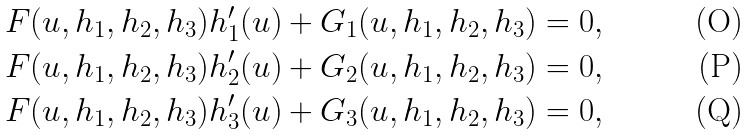Convert formula to latex. <formula><loc_0><loc_0><loc_500><loc_500>& F ( u , h _ { 1 } , h _ { 2 } , h _ { 3 } ) h _ { 1 } ^ { \prime } ( u ) + G _ { 1 } ( u , h _ { 1 } , h _ { 2 } , h _ { 3 } ) = 0 , \\ & F ( u , h _ { 1 } , h _ { 2 } , h _ { 3 } ) h _ { 2 } ^ { \prime } ( u ) + G _ { 2 } ( u , h _ { 1 } , h _ { 2 } , h _ { 3 } ) = 0 , \\ & F ( u , h _ { 1 } , h _ { 2 } , h _ { 3 } ) h _ { 3 } ^ { \prime } ( u ) + G _ { 3 } ( u , h _ { 1 } , h _ { 2 } , h _ { 3 } ) = 0 ,</formula> 